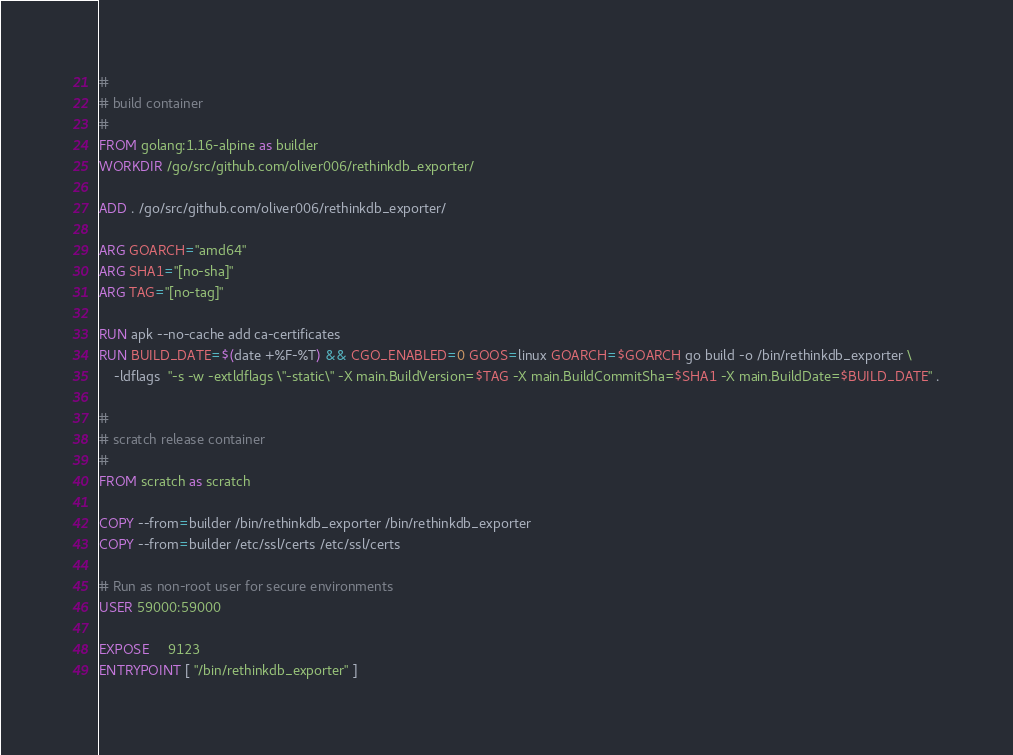<code> <loc_0><loc_0><loc_500><loc_500><_Dockerfile_>#
# build container
#
FROM golang:1.16-alpine as builder
WORKDIR /go/src/github.com/oliver006/rethinkdb_exporter/

ADD . /go/src/github.com/oliver006/rethinkdb_exporter/

ARG GOARCH="amd64"
ARG SHA1="[no-sha]"
ARG TAG="[no-tag]"

RUN apk --no-cache add ca-certificates
RUN BUILD_DATE=$(date +%F-%T) && CGO_ENABLED=0 GOOS=linux GOARCH=$GOARCH go build -o /bin/rethinkdb_exporter \
    -ldflags  "-s -w -extldflags \"-static\" -X main.BuildVersion=$TAG -X main.BuildCommitSha=$SHA1 -X main.BuildDate=$BUILD_DATE" .

#
# scratch release container
#
FROM scratch as scratch

COPY --from=builder /bin/rethinkdb_exporter /bin/rethinkdb_exporter
COPY --from=builder /etc/ssl/certs /etc/ssl/certs

# Run as non-root user for secure environments
USER 59000:59000

EXPOSE     9123
ENTRYPOINT [ "/bin/rethinkdb_exporter" ]
</code> 